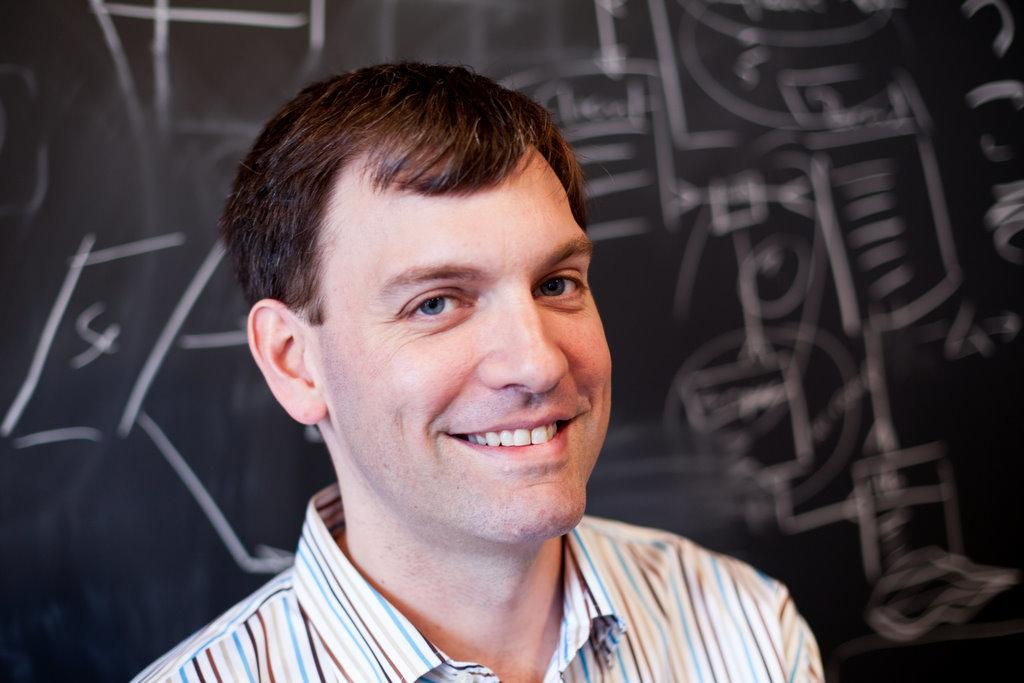What is the main subject of the image? There is a person in the image. Can you describe any additional elements in the background? There is written text on a board in the background of the image. What type of robin is cooking on the stove in the image? There is no robin or stove present in the image. What type of vessel is being used by the person in the image? The provided facts do not mention any vessel being used by the person in the image. 